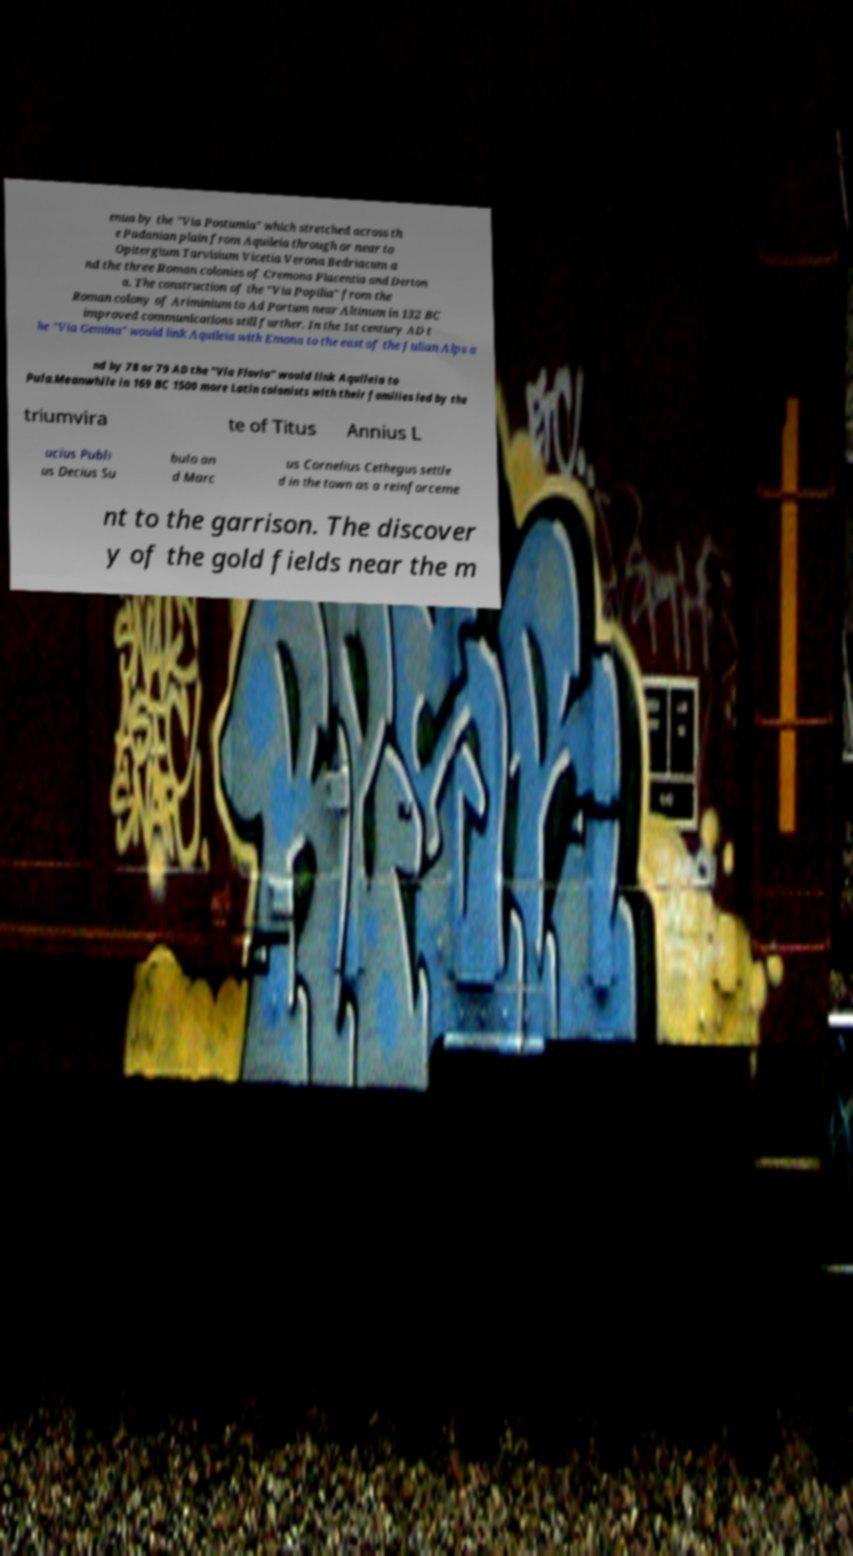What messages or text are displayed in this image? I need them in a readable, typed format. enua by the "Via Postumia" which stretched across th e Padanian plain from Aquileia through or near to Opitergium Tarvisium Vicetia Verona Bedriacum a nd the three Roman colonies of Cremona Placentia and Derton a. The construction of the "Via Popilia" from the Roman colony of Ariminium to Ad Portum near Altinum in 132 BC improved communications still further. In the 1st century AD t he "Via Gemina" would link Aquileia with Emona to the east of the Julian Alps a nd by 78 or 79 AD the "Via Flavia" would link Aquileia to Pula.Meanwhile in 169 BC 1500 more Latin colonists with their families led by the triumvira te of Titus Annius L ucius Publi us Decius Su bulo an d Marc us Cornelius Cethegus settle d in the town as a reinforceme nt to the garrison. The discover y of the gold fields near the m 